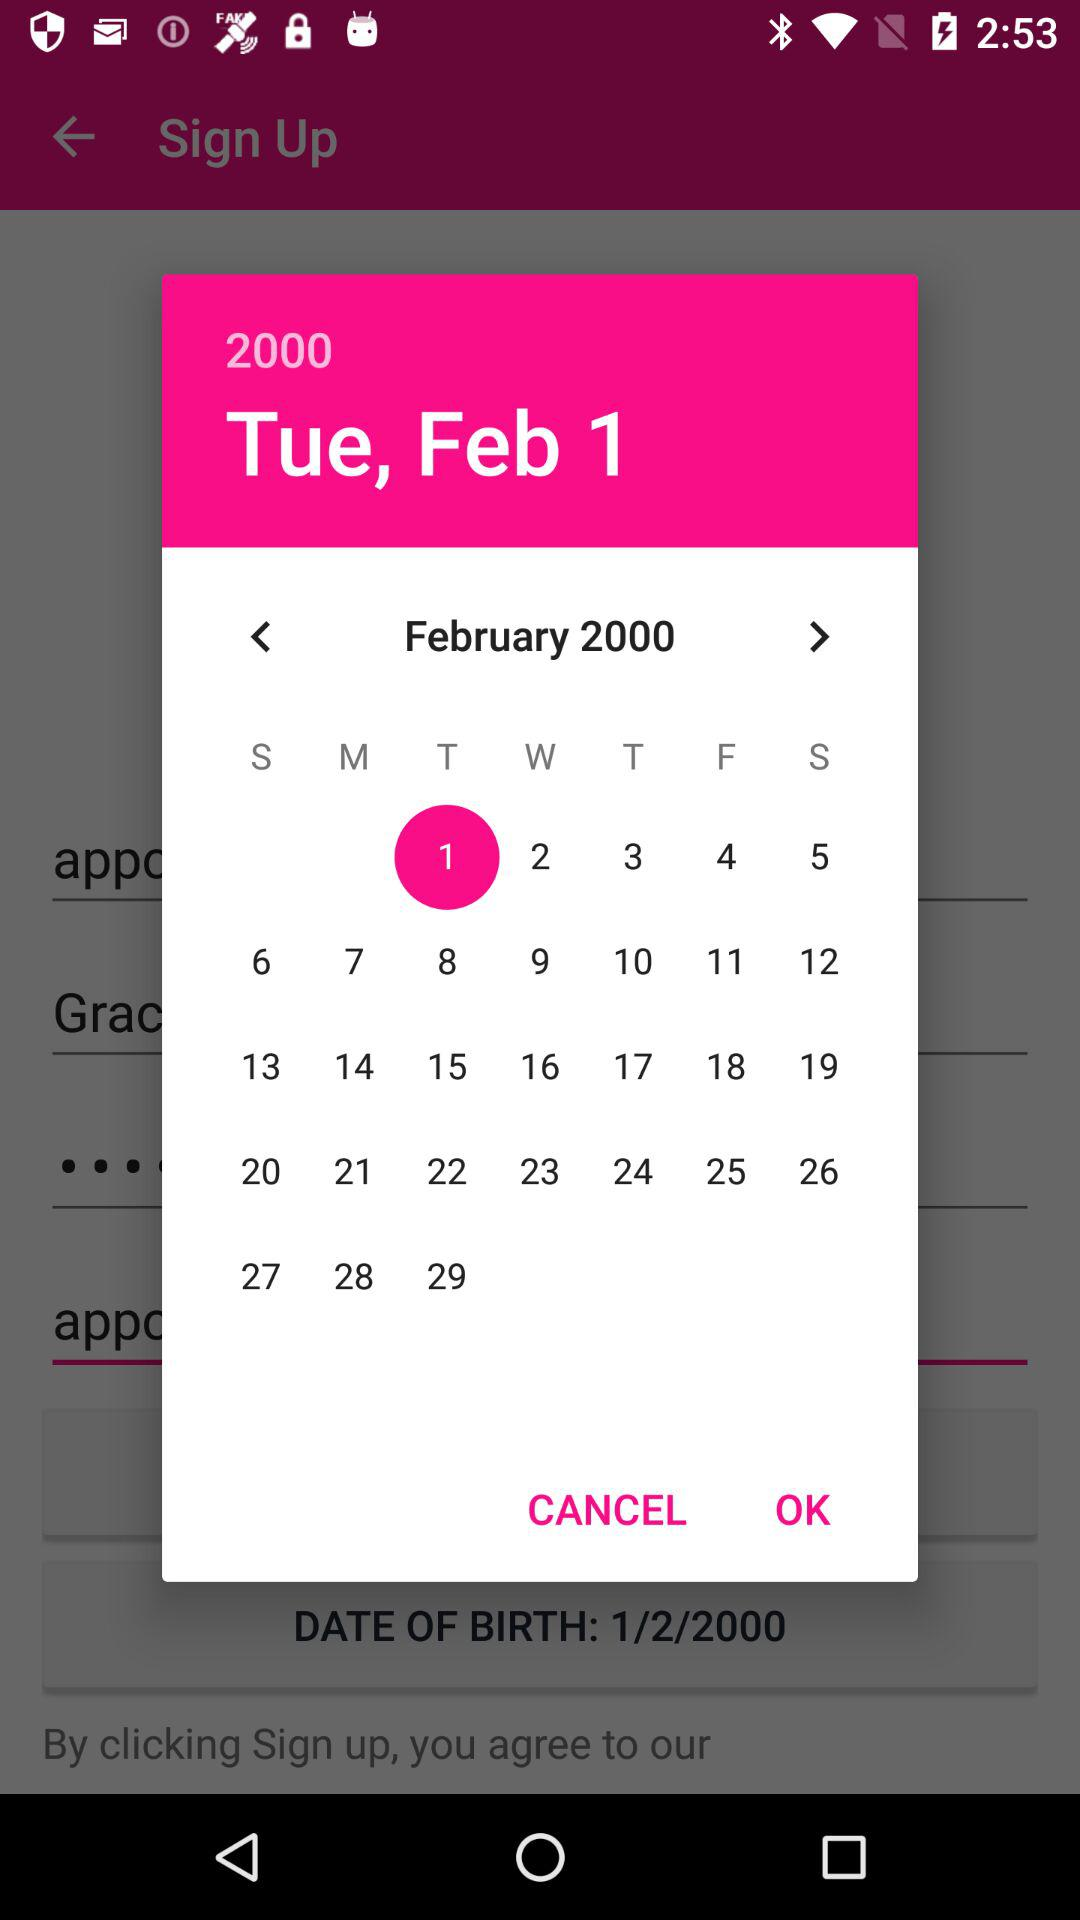What day was February 1, 2000? The day is Tuesday. 